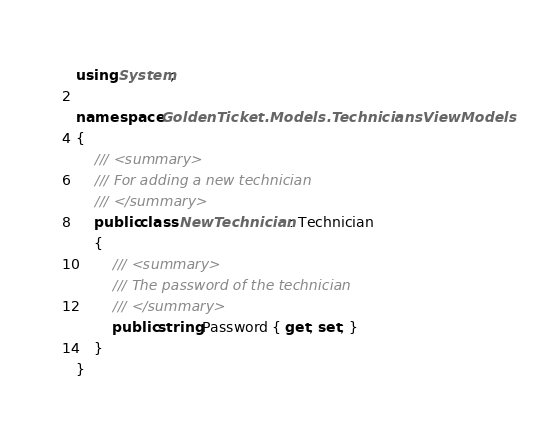<code> <loc_0><loc_0><loc_500><loc_500><_C#_>using System;

namespace GoldenTicket.Models.TechniciansViewModels
{
    /// <summary>
    /// For adding a new technician
    /// </summary>
    public class NewTechnician : Technician
    {
        /// <summary>
        /// The password of the technician
        /// </summary>
        public string Password { get; set; }
    }
}</code> 